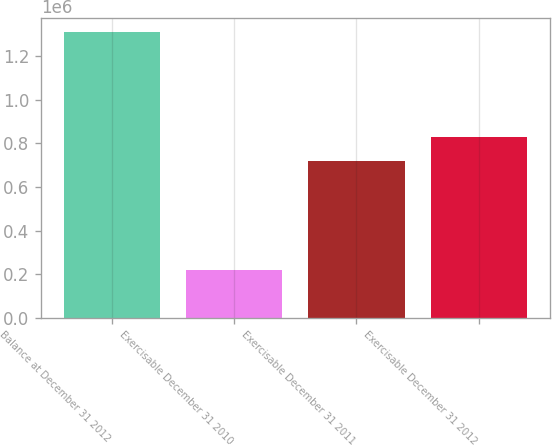Convert chart. <chart><loc_0><loc_0><loc_500><loc_500><bar_chart><fcel>Balance at December 31 2012<fcel>Exercisable December 31 2010<fcel>Exercisable December 31 2011<fcel>Exercisable December 31 2012<nl><fcel>1.30917e+06<fcel>222110<fcel>721210<fcel>829916<nl></chart> 